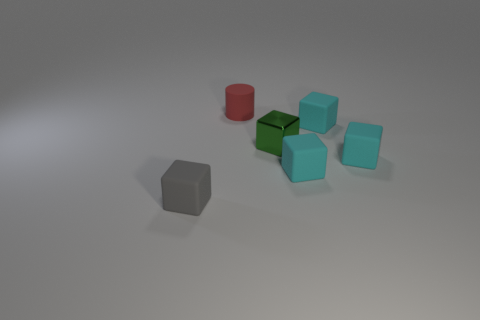Subtract all cyan blocks. How many were subtracted if there are1cyan blocks left? 2 Add 2 red cylinders. How many objects exist? 8 Subtract all cyan blocks. How many blocks are left? 2 Subtract all shiny blocks. How many blocks are left? 4 Add 2 small green metallic objects. How many small green metallic objects are left? 3 Add 1 large blue matte objects. How many large blue matte objects exist? 1 Subtract 0 red balls. How many objects are left? 6 Subtract all blocks. How many objects are left? 1 Subtract 2 cubes. How many cubes are left? 3 Subtract all red blocks. Subtract all purple cylinders. How many blocks are left? 5 